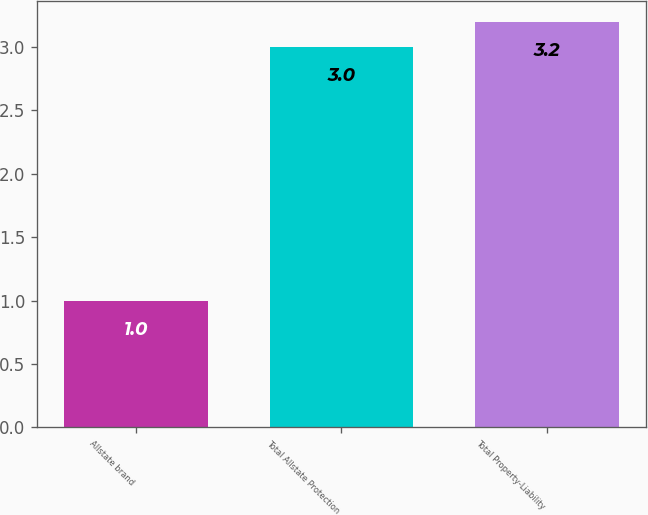<chart> <loc_0><loc_0><loc_500><loc_500><bar_chart><fcel>Allstate brand<fcel>Total Allstate Protection<fcel>Total Property-Liability<nl><fcel>1<fcel>3<fcel>3.2<nl></chart> 